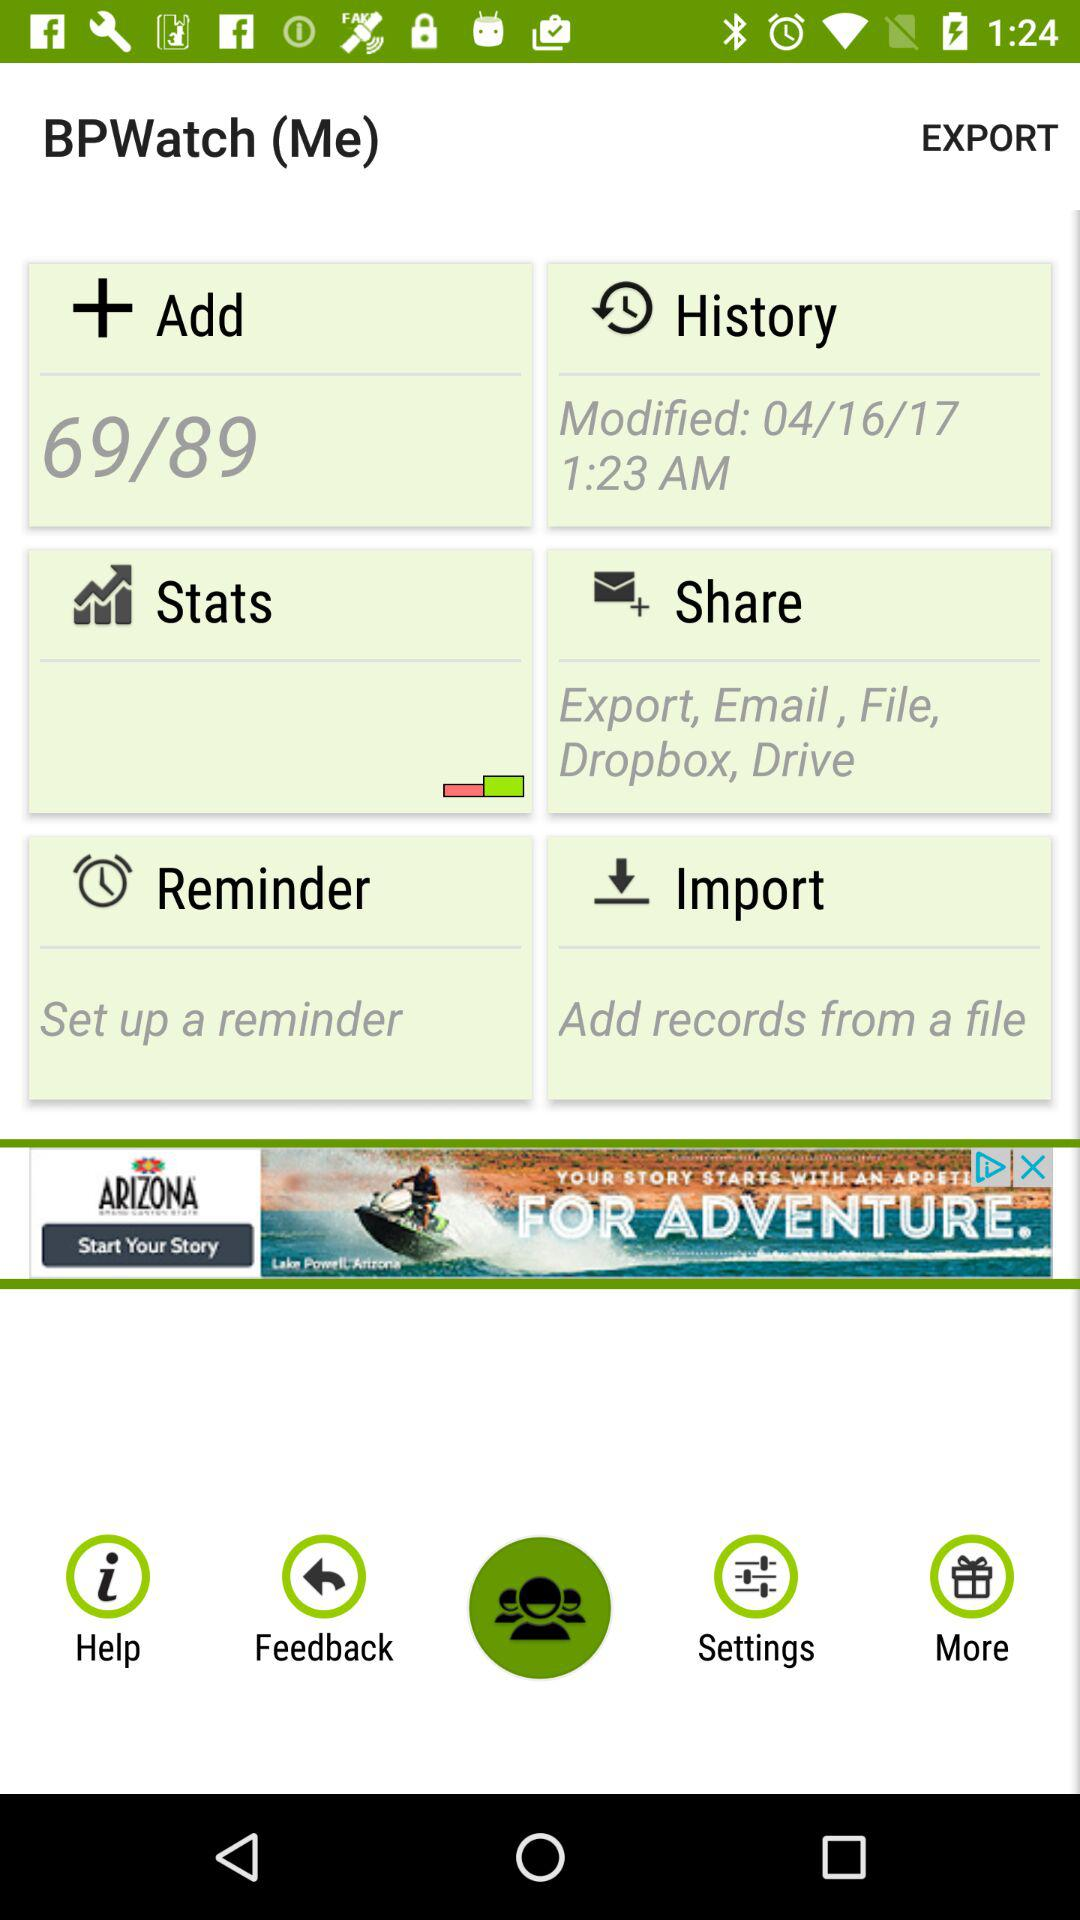When was the history modified? The history was modified on April 16, 2017 at 1:23 AM. 